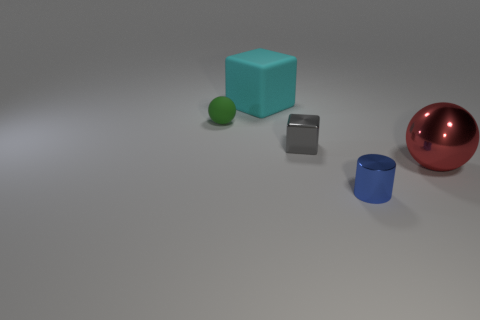Are there any metallic cylinders? Yes, there is one metallic cylinder in the image. It is placed on the left side, with a reflective surface that suggests it is made of metal. 